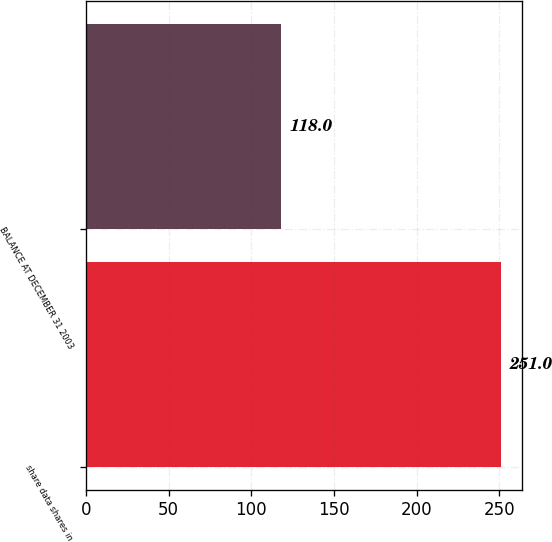Convert chart. <chart><loc_0><loc_0><loc_500><loc_500><bar_chart><fcel>share data shares in<fcel>BALANCE AT DECEMBER 31 2003<nl><fcel>251<fcel>118<nl></chart> 